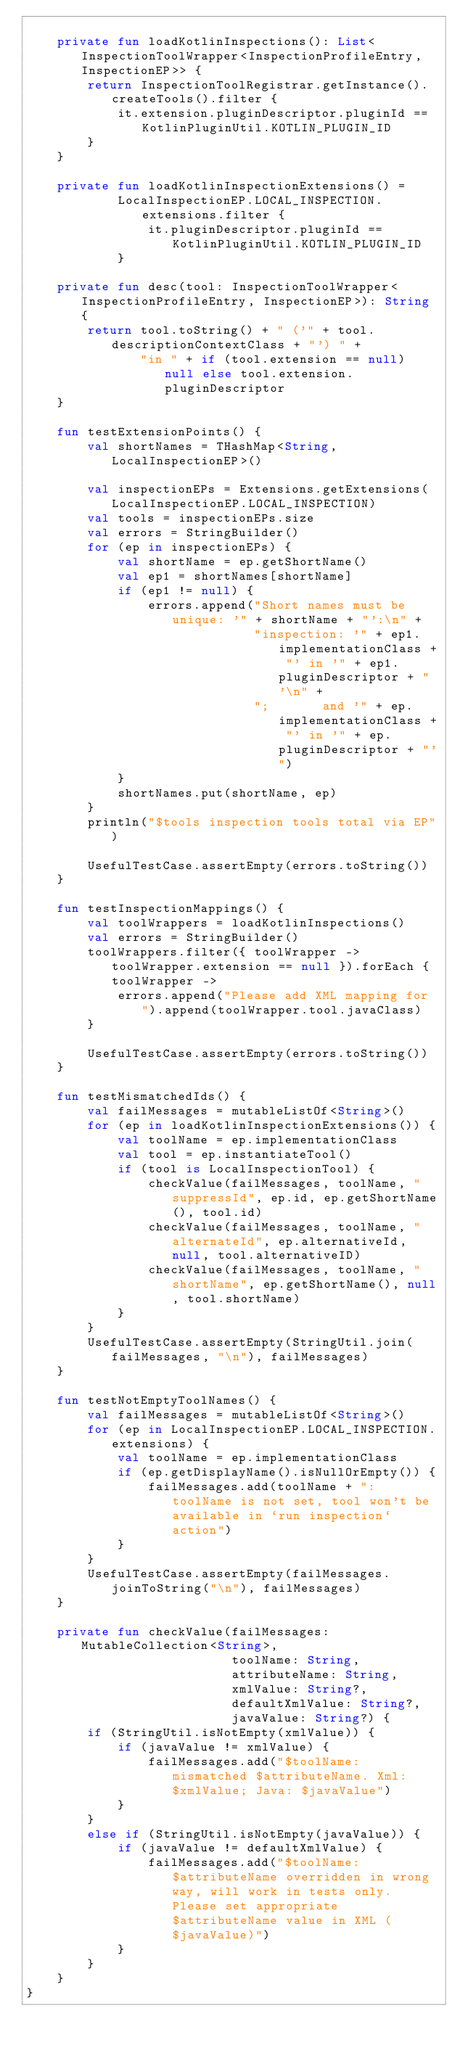Convert code to text. <code><loc_0><loc_0><loc_500><loc_500><_Kotlin_>
    private fun loadKotlinInspections(): List<InspectionToolWrapper<InspectionProfileEntry, InspectionEP>> {
        return InspectionToolRegistrar.getInstance().createTools().filter {
            it.extension.pluginDescriptor.pluginId == KotlinPluginUtil.KOTLIN_PLUGIN_ID
        }
    }

    private fun loadKotlinInspectionExtensions() =
            LocalInspectionEP.LOCAL_INSPECTION.extensions.filter {
                it.pluginDescriptor.pluginId == KotlinPluginUtil.KOTLIN_PLUGIN_ID
            }

    private fun desc(tool: InspectionToolWrapper<InspectionProfileEntry, InspectionEP>): String {
        return tool.toString() + " ('" + tool.descriptionContextClass + "') " +
               "in " + if (tool.extension == null) null else tool.extension.pluginDescriptor
    }

    fun testExtensionPoints() {
        val shortNames = THashMap<String, LocalInspectionEP>()

        val inspectionEPs = Extensions.getExtensions(LocalInspectionEP.LOCAL_INSPECTION)
        val tools = inspectionEPs.size
        val errors = StringBuilder()
        for (ep in inspectionEPs) {
            val shortName = ep.getShortName()
            val ep1 = shortNames[shortName]
            if (ep1 != null) {
                errors.append("Short names must be unique: '" + shortName + "':\n" +
                              "inspection: '" + ep1.implementationClass + "' in '" + ep1.pluginDescriptor + "'\n" +
                              ";       and '" + ep.implementationClass + "' in '" + ep.pluginDescriptor + "'")
            }
            shortNames.put(shortName, ep)
        }
        println("$tools inspection tools total via EP")

        UsefulTestCase.assertEmpty(errors.toString())
    }

    fun testInspectionMappings() {
        val toolWrappers = loadKotlinInspections()
        val errors = StringBuilder()
        toolWrappers.filter({ toolWrapper -> toolWrapper.extension == null }).forEach { toolWrapper ->
            errors.append("Please add XML mapping for ").append(toolWrapper.tool.javaClass)
        }

        UsefulTestCase.assertEmpty(errors.toString())
    }

    fun testMismatchedIds() {
        val failMessages = mutableListOf<String>()
        for (ep in loadKotlinInspectionExtensions()) {
            val toolName = ep.implementationClass
            val tool = ep.instantiateTool()
            if (tool is LocalInspectionTool) {
                checkValue(failMessages, toolName, "suppressId", ep.id, ep.getShortName(), tool.id)
                checkValue(failMessages, toolName, "alternateId", ep.alternativeId, null, tool.alternativeID)
                checkValue(failMessages, toolName, "shortName", ep.getShortName(), null, tool.shortName)
            }
        }
        UsefulTestCase.assertEmpty(StringUtil.join(failMessages, "\n"), failMessages)
    }

    fun testNotEmptyToolNames() {
        val failMessages = mutableListOf<String>()
        for (ep in LocalInspectionEP.LOCAL_INSPECTION.extensions) {
            val toolName = ep.implementationClass
            if (ep.getDisplayName().isNullOrEmpty()) {
                failMessages.add(toolName + ": toolName is not set, tool won't be available in `run inspection` action")
            }
        }
        UsefulTestCase.assertEmpty(failMessages.joinToString("\n"), failMessages)
    }

    private fun checkValue(failMessages: MutableCollection<String>,
                           toolName: String,
                           attributeName: String,
                           xmlValue: String?,
                           defaultXmlValue: String?,
                           javaValue: String?) {
        if (StringUtil.isNotEmpty(xmlValue)) {
            if (javaValue != xmlValue) {
                failMessages.add("$toolName: mismatched $attributeName. Xml: $xmlValue; Java: $javaValue")
            }
        }
        else if (StringUtil.isNotEmpty(javaValue)) {
            if (javaValue != defaultXmlValue) {
                failMessages.add("$toolName: $attributeName overridden in wrong way, will work in tests only. Please set appropriate $attributeName value in XML ($javaValue)")
            }
        }
    }
}
</code> 